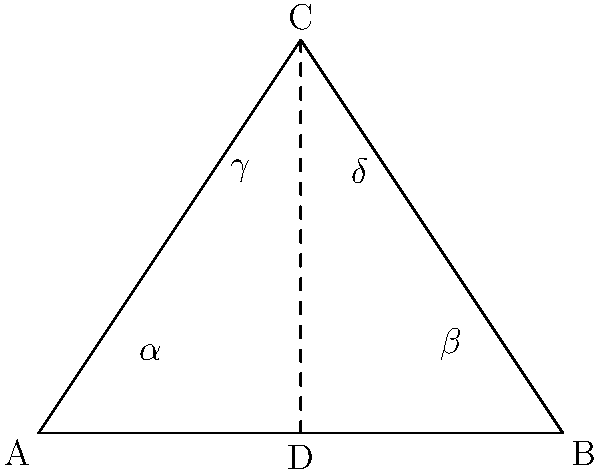In the diagram above, which represents different shooting stances, triangle ABC is isosceles with AB = BC. If $\angle BAC = 50°$, determine the measure of $\angle BCA$. How does this relate to the congruence of angles $\gamma$ and $\delta$? Let's approach this step-by-step:

1) First, recall that in an isosceles triangle, the angles opposite the equal sides are congruent. Here, AB = BC, so $\angle BAC = \angle BCA$.

2) We're given that $\angle BAC = 50°$, so $\angle BCA$ must also be 50°.

3) In any triangle, the sum of all angles is 180°. So we can find $\angle ABC$:
   $\angle ABC = 180° - (\angle BAC + \angle BCA) = 180° - (50° + 50°) = 80°$

4) Now, let's consider the line CD. This line bisects $\angle ACB$, creating two congruent angles: $\gamma$ and $\delta$.

5) Since CD bisects $\angle ACB$, each of these angles ($\gamma$ and $\delta$) is half of $\angle ACB$.
   $\gamma = \delta = \frac{1}{2} \angle ACB = \frac{1}{2} (50°) = 25°$

6) The congruence of $\gamma$ and $\delta$ is crucial in shooting stances. It ensures that the shot is balanced and centered, which is essential for accuracy in basketball shooting techniques.
Answer: $\angle BCA = 50°$; $\gamma$ and $\delta$ are congruent, each measuring 25°. 